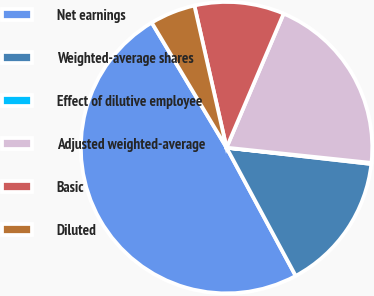Convert chart. <chart><loc_0><loc_0><loc_500><loc_500><pie_chart><fcel>Net earnings<fcel>Weighted-average shares<fcel>Effect of dilutive employee<fcel>Adjusted weighted-average<fcel>Basic<fcel>Diluted<nl><fcel>49.29%<fcel>15.34%<fcel>0.12%<fcel>20.26%<fcel>9.95%<fcel>5.04%<nl></chart> 